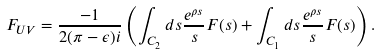<formula> <loc_0><loc_0><loc_500><loc_500>F _ { U V } = \frac { - 1 } { 2 ( \pi - \epsilon ) i } \left ( \int _ { C _ { 2 } } d s \frac { e ^ { \rho s } } { s } F ( s ) + \int _ { C _ { 1 } } d s \frac { e ^ { \rho s } } { s } F ( s ) \right ) .</formula> 